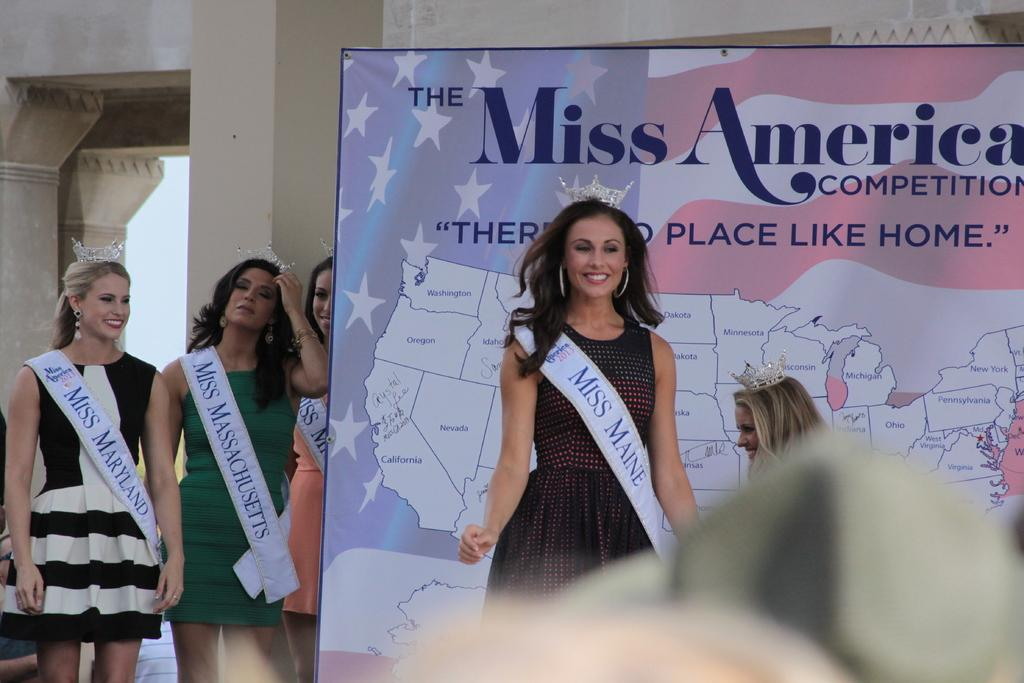<image>
Write a terse but informative summary of the picture. Woman wearing a white banner that says Miss Maine on it. 